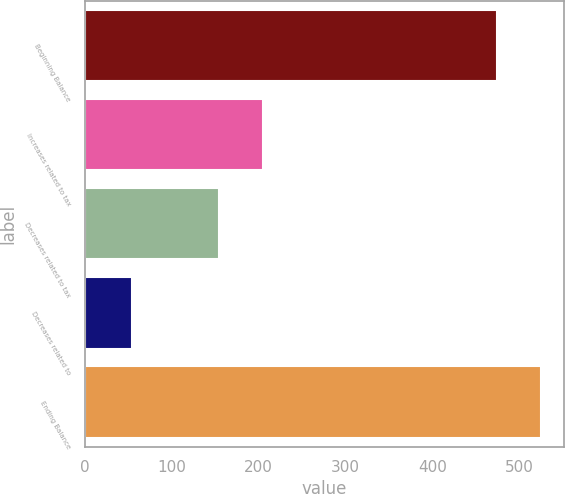Convert chart. <chart><loc_0><loc_0><loc_500><loc_500><bar_chart><fcel>Beginning Balance<fcel>Increases related to tax<fcel>Decreases related to tax<fcel>Decreases related to<fcel>Ending Balance<nl><fcel>475<fcel>204.82<fcel>154.63<fcel>54.25<fcel>525.19<nl></chart> 